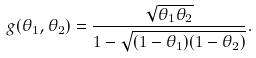Convert formula to latex. <formula><loc_0><loc_0><loc_500><loc_500>g ( \theta _ { 1 } , \theta _ { 2 } ) = \frac { \sqrt { \theta _ { 1 } \theta _ { 2 } } } { 1 - \sqrt { ( 1 - \theta _ { 1 } ) ( 1 - \theta _ { 2 } ) } } .</formula> 